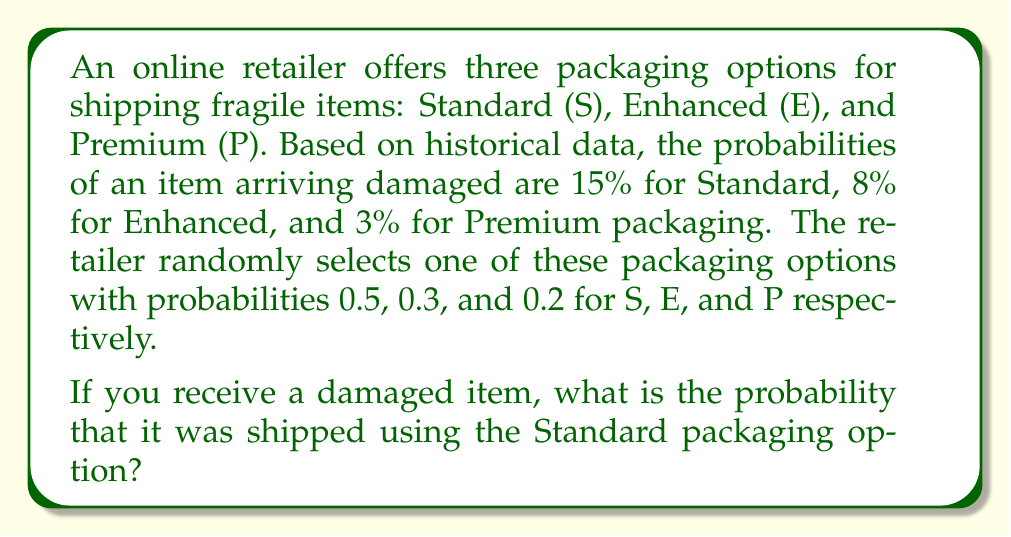Give your solution to this math problem. To solve this problem, we'll use Bayes' Theorem. Let's define our events:
- D: The item is damaged
- S: Standard packaging was used
- E: Enhanced packaging was used
- P: Premium packaging was used

We want to find P(S|D), the probability that Standard packaging was used given that the item is damaged.

Bayes' Theorem states:

$$ P(S|D) = \frac{P(D|S) \cdot P(S)}{P(D)} $$

We know:
- P(D|S) = 0.15 (probability of damage given Standard packaging)
- P(S) = 0.5 (probability of using Standard packaging)
- P(D|E) = 0.08 (probability of damage given Enhanced packaging)
- P(E) = 0.3 (probability of using Enhanced packaging)
- P(D|P) = 0.03 (probability of damage given Premium packaging)
- P(P) = 0.2 (probability of using Premium packaging)

We need to calculate P(D) using the law of total probability:

$$ P(D) = P(D|S) \cdot P(S) + P(D|E) \cdot P(E) + P(D|P) \cdot P(P) $$

$$ P(D) = 0.15 \cdot 0.5 + 0.08 \cdot 0.3 + 0.03 \cdot 0.2 $$
$$ P(D) = 0.075 + 0.024 + 0.006 = 0.105 $$

Now we can apply Bayes' Theorem:

$$ P(S|D) = \frac{0.15 \cdot 0.5}{0.105} = \frac{0.075}{0.105} = \frac{75}{105} = \frac{5}{7} \approx 0.7143 $$

Therefore, the probability that Standard packaging was used, given that the item is damaged, is $\frac{5}{7}$ or approximately 71.43%.
Answer: $\frac{5}{7}$ or approximately 0.7143 (71.43%) 